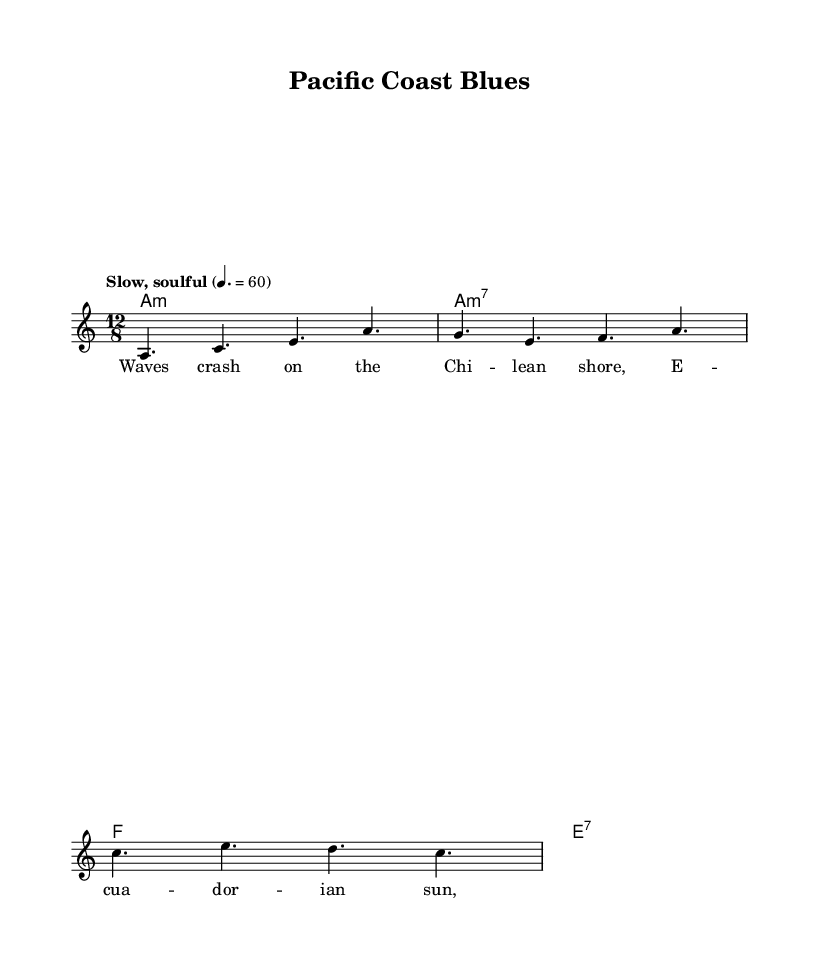What is the key signature of this music? The key signature displayed is A minor, which typically has no sharps or flats. This can be determined by looking at the key indication in the sheet music.
Answer: A minor What is the time signature of this music? The time signature shown is 12/8, which indicates there are 12 eighth notes in each measure. This can be established by reading the time signature notation in the sheet music.
Answer: 12/8 What is the tempo marking in the sheet music? The tempo marking indicates "Slow, soulful," which suggests a tranquil rhythmic feel. It is located near the top of the score and includes a metronome marking of 60 beats per minute.
Answer: Slow, soulful How many measures are in the melody section? The melody consists of four measures as indicated by the separation of notes and rests within the staff. Each group of notes between the bar lines represents a single measure.
Answer: Four What type of chords are primarily used in this blues piece? The primary chords used are minor and dominant seventh chords, which are typical in blues music. The harmonies section shows the chords A minor, A minor 7, F, and E7.
Answer: Minor and dominant seventh What is the main theme of the lyrics in this blues ballad? The main theme of the lyrics revolves around coastal imagery and admiration for the beauty of the Chilean and Ecuadorian shores, as evident from phrases like "Waves crash on the Chilean shore."
Answer: Coastal imagery 